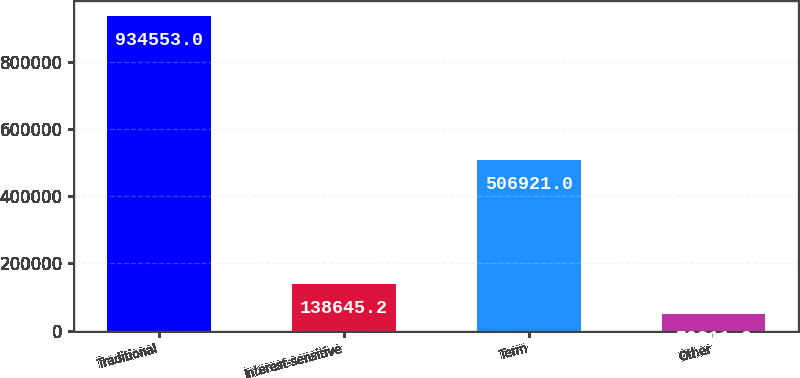Convert chart to OTSL. <chart><loc_0><loc_0><loc_500><loc_500><bar_chart><fcel>Traditional<fcel>Interest-sensitive<fcel>Term<fcel>Other<nl><fcel>934553<fcel>138645<fcel>506921<fcel>50211<nl></chart> 